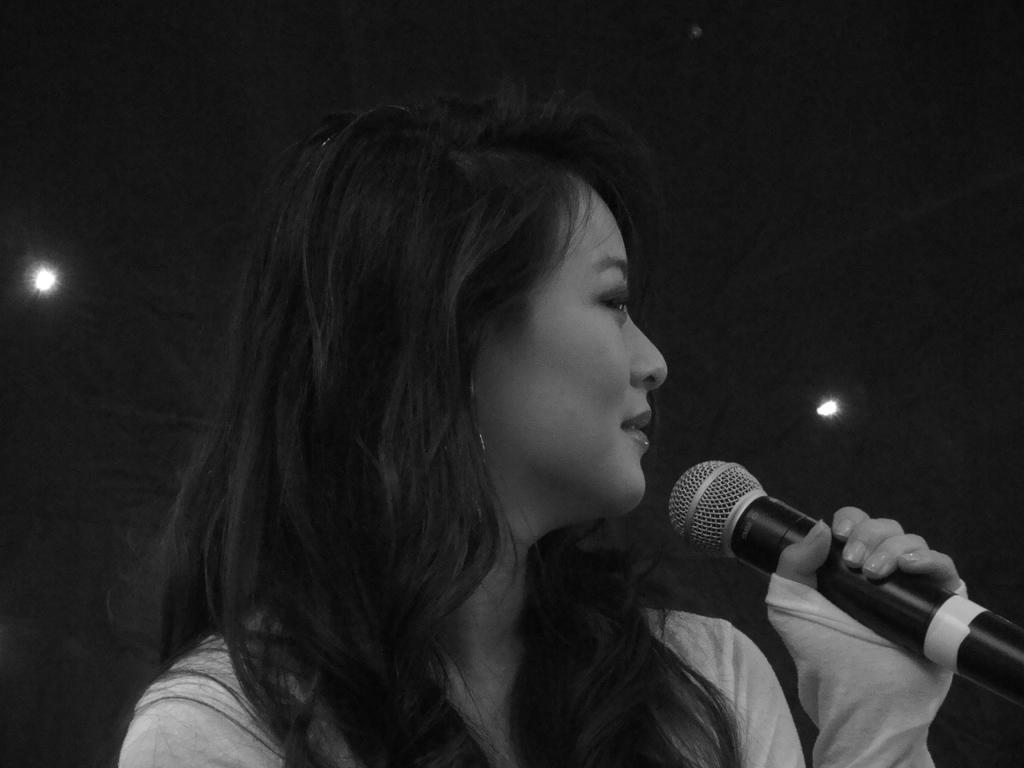Who is the main subject in the image? There is a woman in the image. What is the woman holding in the image? The woman is holding a mic. How many bikes can be seen in the image? There are no bikes present in the image. Can you describe the woman's reaction to a sneeze in the image? There is no sneeze or any indication of a sneeze in the image. 